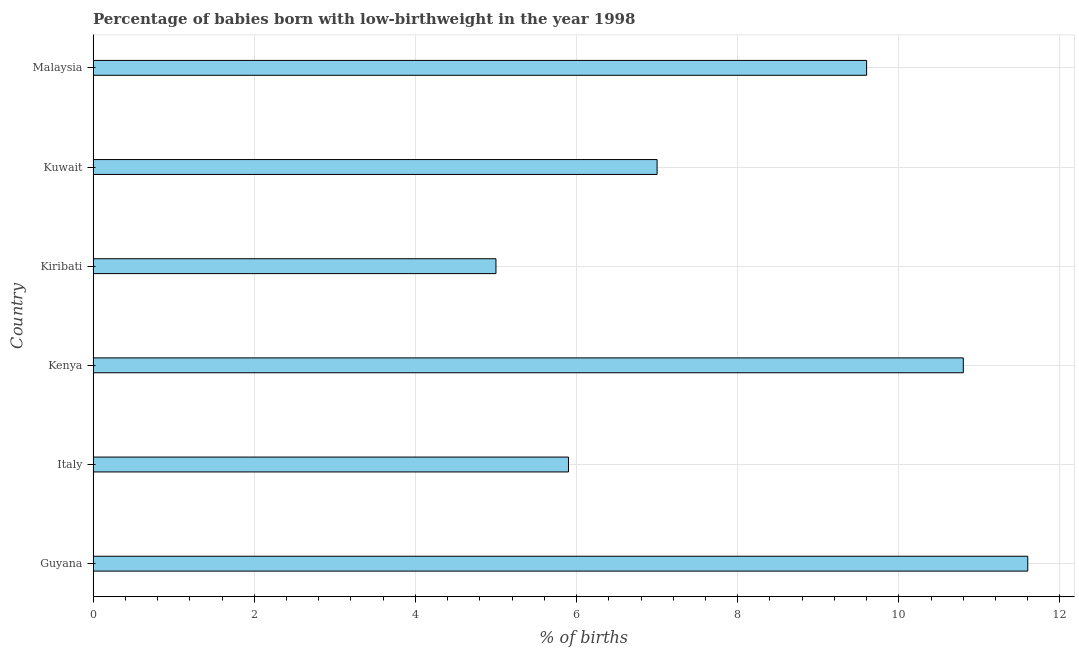Does the graph contain grids?
Give a very brief answer. Yes. What is the title of the graph?
Offer a terse response. Percentage of babies born with low-birthweight in the year 1998. What is the label or title of the X-axis?
Provide a succinct answer. % of births. What is the label or title of the Y-axis?
Your answer should be very brief. Country. Across all countries, what is the minimum percentage of babies who were born with low-birthweight?
Provide a short and direct response. 5. In which country was the percentage of babies who were born with low-birthweight maximum?
Your answer should be very brief. Guyana. In which country was the percentage of babies who were born with low-birthweight minimum?
Give a very brief answer. Kiribati. What is the sum of the percentage of babies who were born with low-birthweight?
Your response must be concise. 49.9. What is the average percentage of babies who were born with low-birthweight per country?
Ensure brevity in your answer.  8.32. What is the median percentage of babies who were born with low-birthweight?
Ensure brevity in your answer.  8.3. What is the ratio of the percentage of babies who were born with low-birthweight in Guyana to that in Kiribati?
Your response must be concise. 2.32. Is the percentage of babies who were born with low-birthweight in Kuwait less than that in Malaysia?
Ensure brevity in your answer.  Yes. Is the difference between the percentage of babies who were born with low-birthweight in Kiribati and Malaysia greater than the difference between any two countries?
Offer a terse response. No. What is the difference between the highest and the lowest percentage of babies who were born with low-birthweight?
Your answer should be very brief. 6.6. In how many countries, is the percentage of babies who were born with low-birthweight greater than the average percentage of babies who were born with low-birthweight taken over all countries?
Provide a short and direct response. 3. How many countries are there in the graph?
Provide a short and direct response. 6. What is the difference between two consecutive major ticks on the X-axis?
Offer a very short reply. 2. What is the % of births in Italy?
Your answer should be very brief. 5.9. What is the % of births of Kiribati?
Your response must be concise. 5. What is the difference between the % of births in Guyana and Italy?
Keep it short and to the point. 5.7. What is the difference between the % of births in Guyana and Kenya?
Make the answer very short. 0.8. What is the difference between the % of births in Italy and Kuwait?
Make the answer very short. -1.1. What is the difference between the % of births in Kenya and Malaysia?
Give a very brief answer. 1.2. What is the difference between the % of births in Kiribati and Kuwait?
Give a very brief answer. -2. What is the difference between the % of births in Kiribati and Malaysia?
Offer a terse response. -4.6. What is the ratio of the % of births in Guyana to that in Italy?
Give a very brief answer. 1.97. What is the ratio of the % of births in Guyana to that in Kenya?
Provide a succinct answer. 1.07. What is the ratio of the % of births in Guyana to that in Kiribati?
Provide a succinct answer. 2.32. What is the ratio of the % of births in Guyana to that in Kuwait?
Give a very brief answer. 1.66. What is the ratio of the % of births in Guyana to that in Malaysia?
Your answer should be very brief. 1.21. What is the ratio of the % of births in Italy to that in Kenya?
Your answer should be very brief. 0.55. What is the ratio of the % of births in Italy to that in Kiribati?
Provide a short and direct response. 1.18. What is the ratio of the % of births in Italy to that in Kuwait?
Your answer should be compact. 0.84. What is the ratio of the % of births in Italy to that in Malaysia?
Give a very brief answer. 0.61. What is the ratio of the % of births in Kenya to that in Kiribati?
Your answer should be compact. 2.16. What is the ratio of the % of births in Kenya to that in Kuwait?
Offer a terse response. 1.54. What is the ratio of the % of births in Kenya to that in Malaysia?
Offer a terse response. 1.12. What is the ratio of the % of births in Kiribati to that in Kuwait?
Make the answer very short. 0.71. What is the ratio of the % of births in Kiribati to that in Malaysia?
Ensure brevity in your answer.  0.52. What is the ratio of the % of births in Kuwait to that in Malaysia?
Give a very brief answer. 0.73. 